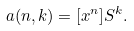<formula> <loc_0><loc_0><loc_500><loc_500>a ( n , k ) = [ x ^ { n } ] S ^ { k } .</formula> 